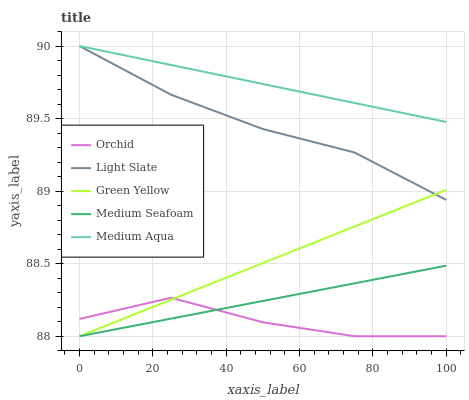Does Green Yellow have the minimum area under the curve?
Answer yes or no. No. Does Green Yellow have the maximum area under the curve?
Answer yes or no. No. Is Green Yellow the smoothest?
Answer yes or no. No. Is Green Yellow the roughest?
Answer yes or no. No. Does Medium Aqua have the lowest value?
Answer yes or no. No. Does Green Yellow have the highest value?
Answer yes or no. No. Is Orchid less than Light Slate?
Answer yes or no. Yes. Is Light Slate greater than Medium Seafoam?
Answer yes or no. Yes. Does Orchid intersect Light Slate?
Answer yes or no. No. 